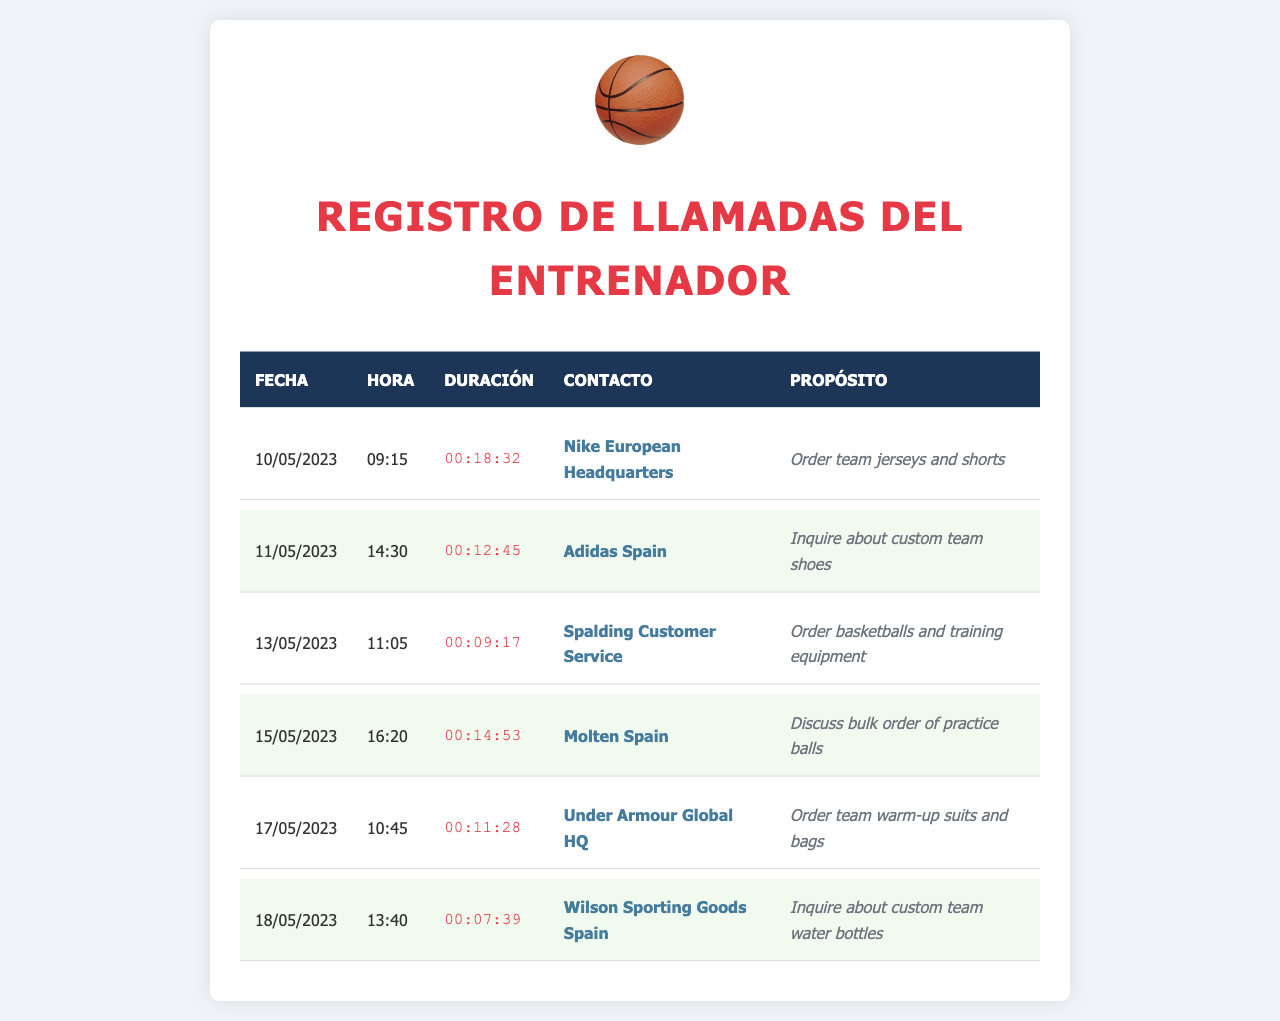¿Cuál es el contacto con el cual se hizo el pedido de camisetas y pantalones cortos? La llamada realizada a Nike European Headquarters fue para pedir las camisetas y pantalones cortos del equipo.
Answer: Nike European Headquarters ¿Cuál es la duración de la llamada a Adidas España? La duración de la llamada realizada a Adidas España el 11 de mayo de 2023 fue de 12 minutos y 45 segundos.
Answer: 00:12:45 ¿Cuántas llamadas se hicieron en total? Se realizaron seis llamadas en total según el registro de llamadas.
Answer: 6 ¿Qué día se hizo la llamada para pedir balones de baloncesto y equipo de entrenamiento? La llamada a Spalding Customer Service para pedir balones de baloncesto y equipo de entrenamiento se hizo el 13 de mayo de 2023.
Answer: 13/05/2023 ¿Cuál fue el propósito de la llamada realizada a Wilson Sporting Goods España? El propósito de la llamada a Wilson Sporting Goods España fue preguntar sobre botellas de agua personalizadas para el equipo.
Answer: Inquire about custom team water bottles ¿Cuál fue la duración más corta de las llamadas registradas? La duración más corta de las llamadas registradas fue de 7 minutos y 39 segundos.
Answer: 00:07:39 ¿Qué contacto se discutió para un pedido de pelotas de práctica? La llamada realizada a Molten España fue para discutir un pedido a granel de pelotas de práctica.
Answer: Molten España ¿Qué tipo de productos se pidieron a Under Armour Global HQ? Se ordenaron trajes de calentamiento y bolsas para el equipo a Under Armour Global HQ.
Answer: Trajes de calentamiento y bolsas 